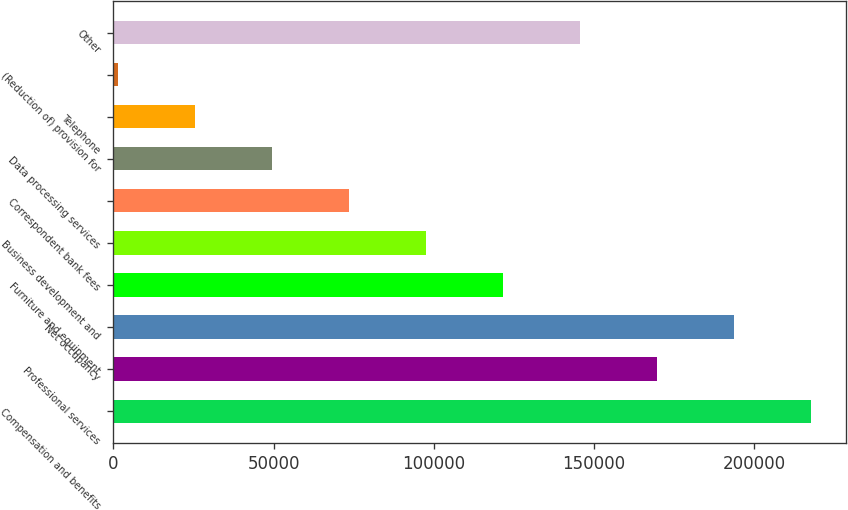Convert chart to OTSL. <chart><loc_0><loc_0><loc_500><loc_500><bar_chart><fcel>Compensation and benefits<fcel>Professional services<fcel>Net occupancy<fcel>Furniture and equipment<fcel>Business development and<fcel>Correspondent bank fees<fcel>Data processing services<fcel>Telephone<fcel>(Reduction of) provision for<fcel>Other<nl><fcel>217802<fcel>169746<fcel>193774<fcel>121690<fcel>97661.4<fcel>73633.3<fcel>49605.2<fcel>25577.1<fcel>1549<fcel>145718<nl></chart> 